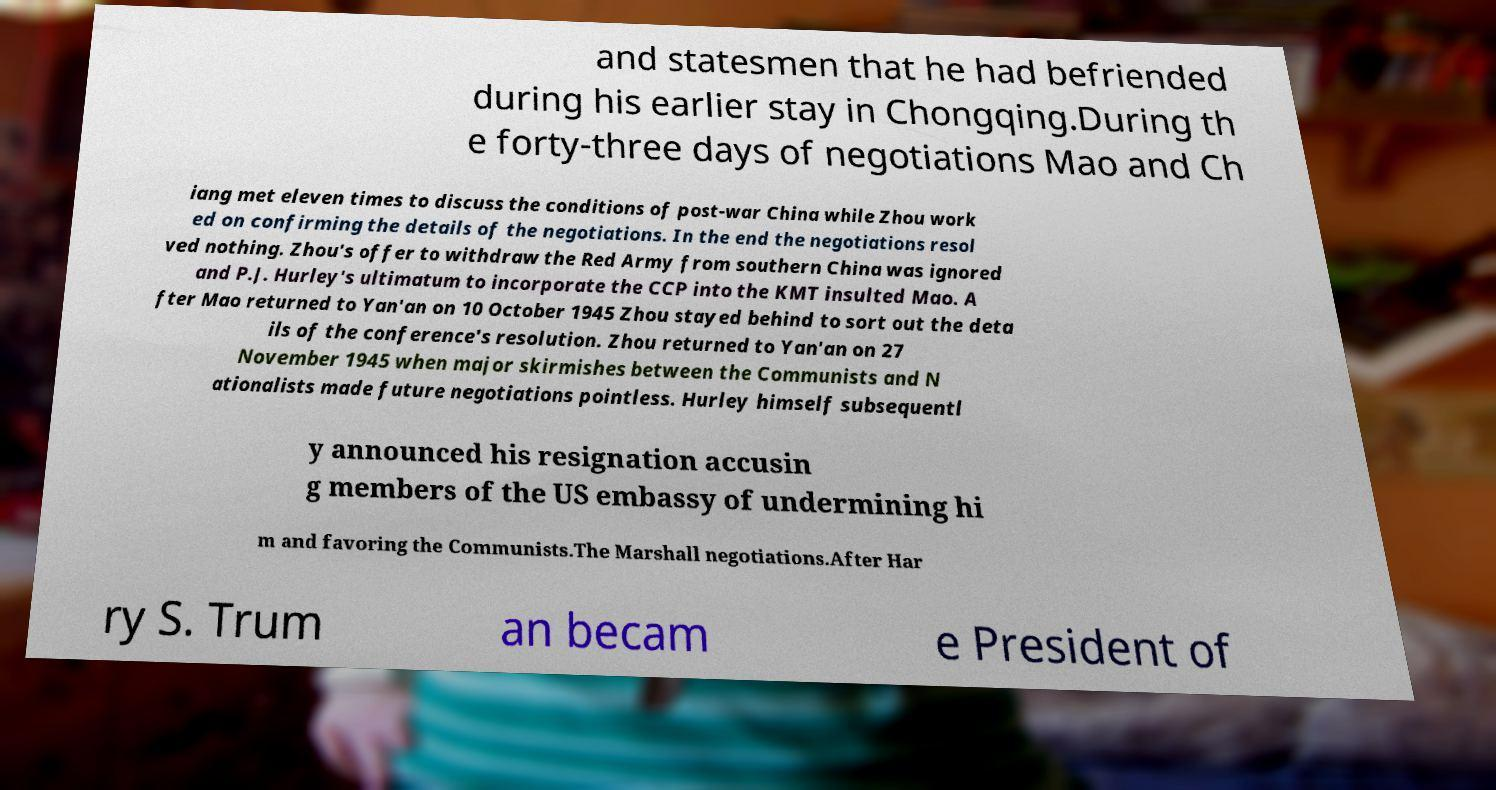Can you accurately transcribe the text from the provided image for me? and statesmen that he had befriended during his earlier stay in Chongqing.During th e forty-three days of negotiations Mao and Ch iang met eleven times to discuss the conditions of post-war China while Zhou work ed on confirming the details of the negotiations. In the end the negotiations resol ved nothing. Zhou's offer to withdraw the Red Army from southern China was ignored and P.J. Hurley's ultimatum to incorporate the CCP into the KMT insulted Mao. A fter Mao returned to Yan'an on 10 October 1945 Zhou stayed behind to sort out the deta ils of the conference's resolution. Zhou returned to Yan'an on 27 November 1945 when major skirmishes between the Communists and N ationalists made future negotiations pointless. Hurley himself subsequentl y announced his resignation accusin g members of the US embassy of undermining hi m and favoring the Communists.The Marshall negotiations.After Har ry S. Trum an becam e President of 